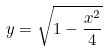<formula> <loc_0><loc_0><loc_500><loc_500>y = \sqrt { 1 - \frac { x ^ { 2 } } { 4 } }</formula> 